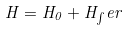Convert formula to latex. <formula><loc_0><loc_0><loc_500><loc_500>H = H _ { 0 } + H _ { \int } e r</formula> 